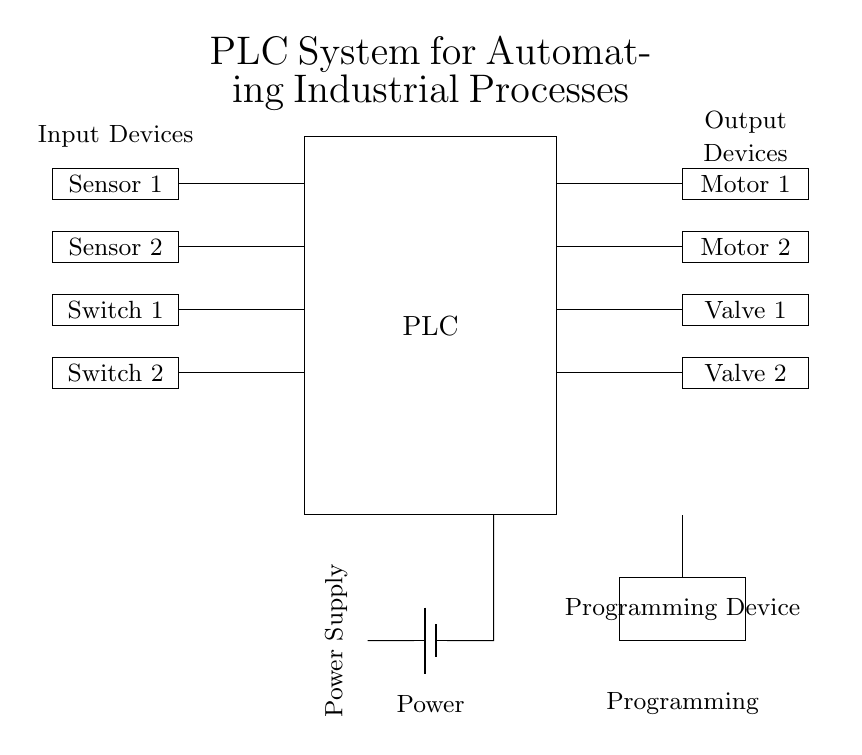What type of control system is represented in this diagram? The diagram represents a programmable logic controller (PLC) system, which is designed for automating industrial processes. The PLC's function can be inferred from the components and layout presented in the diagram.
Answer: Programmable logic controller How many input devices are there in the circuit? There are four input devices depicted in the diagram: Sensor 1, Sensor 2, Switch 1, and Switch 2. This count is derived directly from the rectangles labeled as input devices on the left side of the circuit.
Answer: Four What is connected to the power supply? The power supply is connected to the PLC, which is the primary control unit in the circuit diagram. Tracing the connections shows that the power leads directly into the PLC block.
Answer: PLC What is the function of Motor 1? Motor 1 is an output device in this PLC system that is typically used to perform a mechanical function as directed by the PLC based on input signals. Its exact function can depend on the input conditions and programming logic, but generally serves as an actuator in industrial applications.
Answer: Actuator Which device is used for programming the PLC? The programming device is represented in the diagram as a rectangle labeled "Programming Device." This device is essential for inputting control logic and parameters into the PLC.
Answer: Programming Device What are the output devices in this circuit? The output devices include Motor 1, Motor 2, Valve 1, and Valve 2. These devices are responsible for executing the commands dictated by the PLC based on the inputs it receives. Clearly, these are denoted in the rectangular shapes on the right side of the diagram.
Answer: Motor 1, Motor 2, Valve 1, Valve 2 What type of sensors are indicated in the circuit? The circuit includes two types of input devices: sensors and switches. Specifically, Sensor 1 and Sensor 2 serve as detection devices providing data to the PLC, while Switch 1 and Switch 2 are manual input devices.
Answer: Sensors and switches 